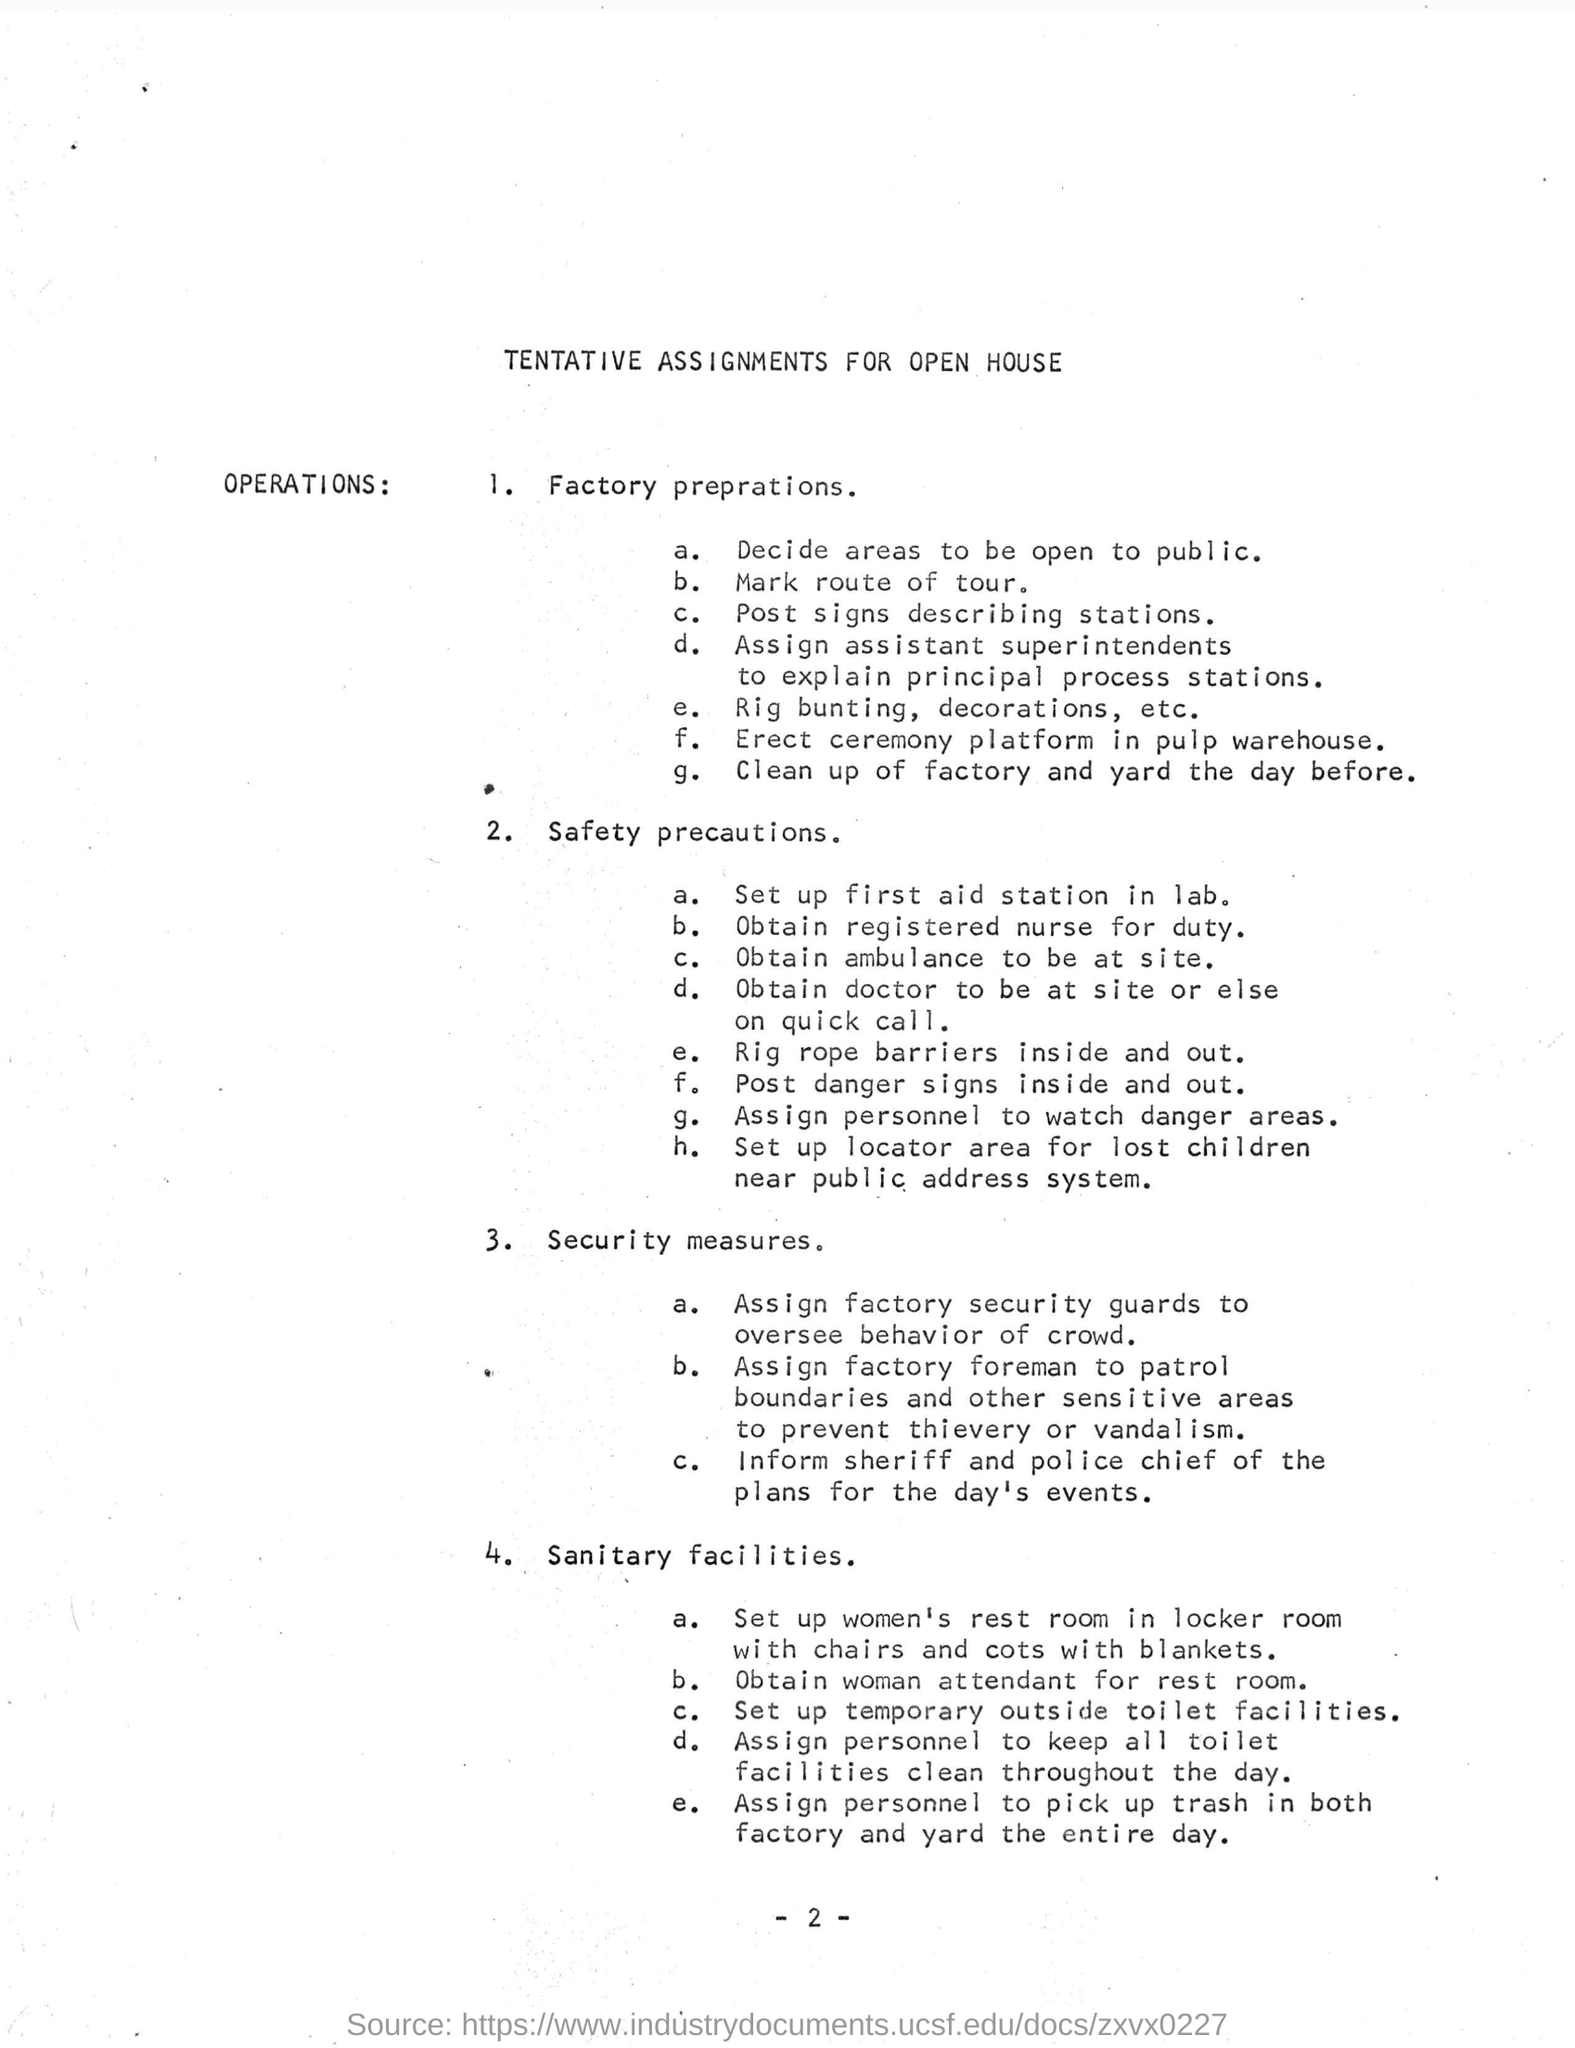Where is to set up first aid station?
Your answer should be very brief. Lab. Who is assigned to oversee behaviour of crowd?
Your answer should be very brief. Factory security guards. 